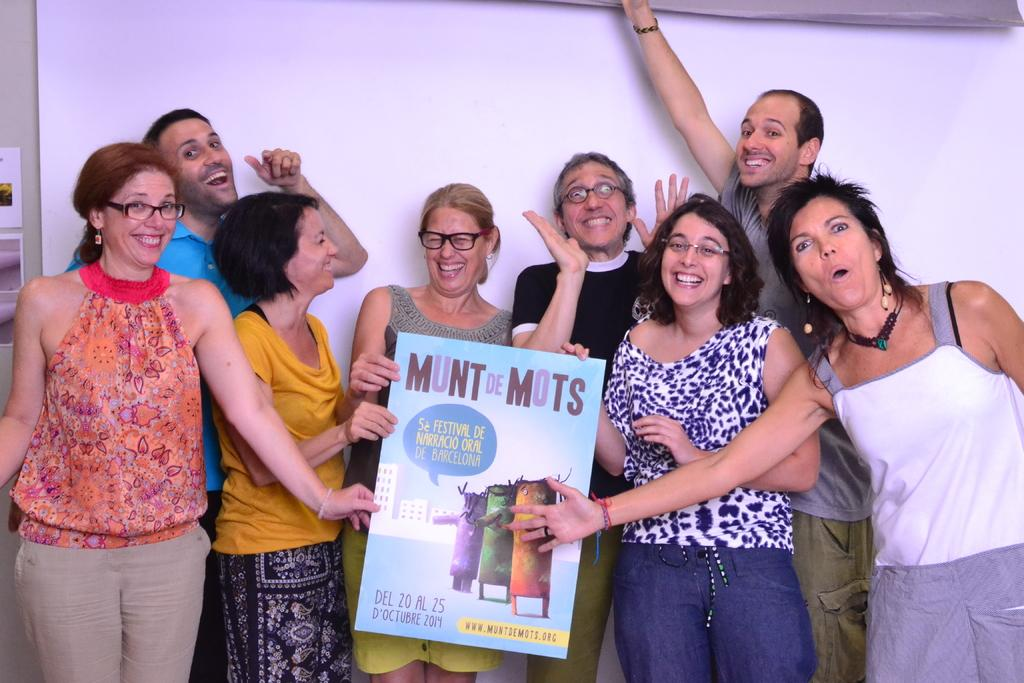Who or what is present in the image? There are people in the image. What are the people wearing? The people are wearing clothes. Can you describe any other objects or features in the image? There is a board at the bottom of the image. What type of button is being used to control the title in the image? There is no button or title present in the image; it only features people and a board. 